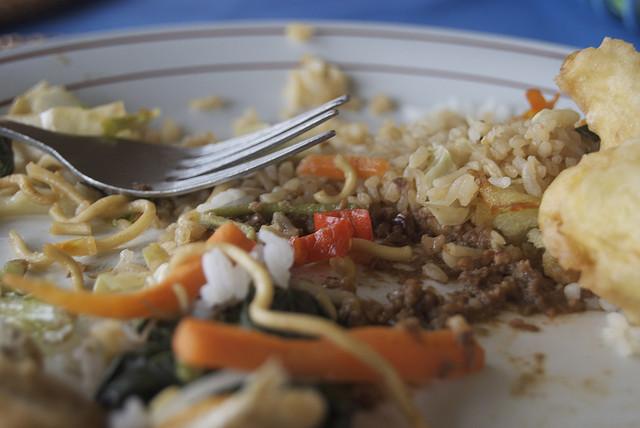Is this breakfast or dinner?
Answer briefly. Dinner. What ethnicity was this recipe?
Short answer required. Chinese. Are they going to eat all of it?
Concise answer only. No. 